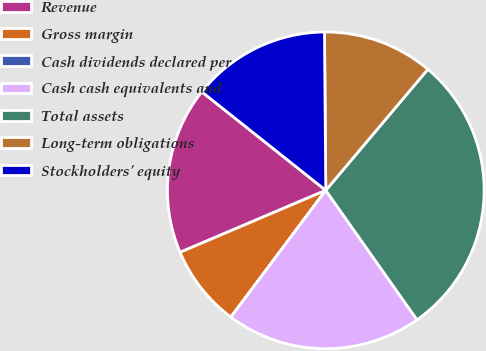<chart> <loc_0><loc_0><loc_500><loc_500><pie_chart><fcel>Revenue<fcel>Gross margin<fcel>Cash dividends declared per<fcel>Cash cash equivalents and<fcel>Total assets<fcel>Long-term obligations<fcel>Stockholders' equity<nl><fcel>17.09%<fcel>8.37%<fcel>0.0%<fcel>20.0%<fcel>29.08%<fcel>11.28%<fcel>14.18%<nl></chart> 